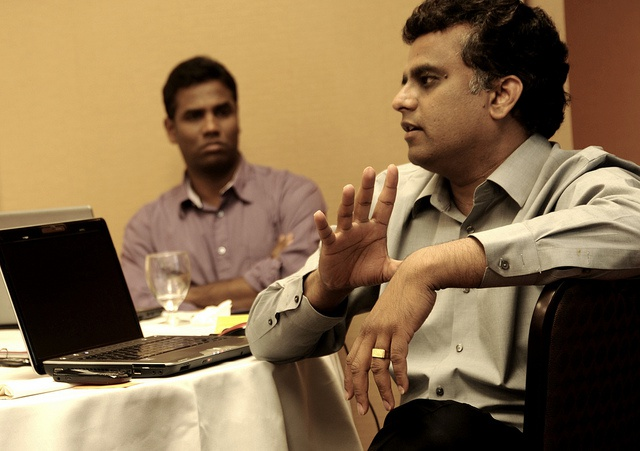Describe the objects in this image and their specific colors. I can see people in tan, black, maroon, and gray tones, dining table in tan, beige, and maroon tones, people in tan, gray, black, and maroon tones, laptop in tan, black, maroon, and gray tones, and chair in tan, black, and maroon tones in this image. 